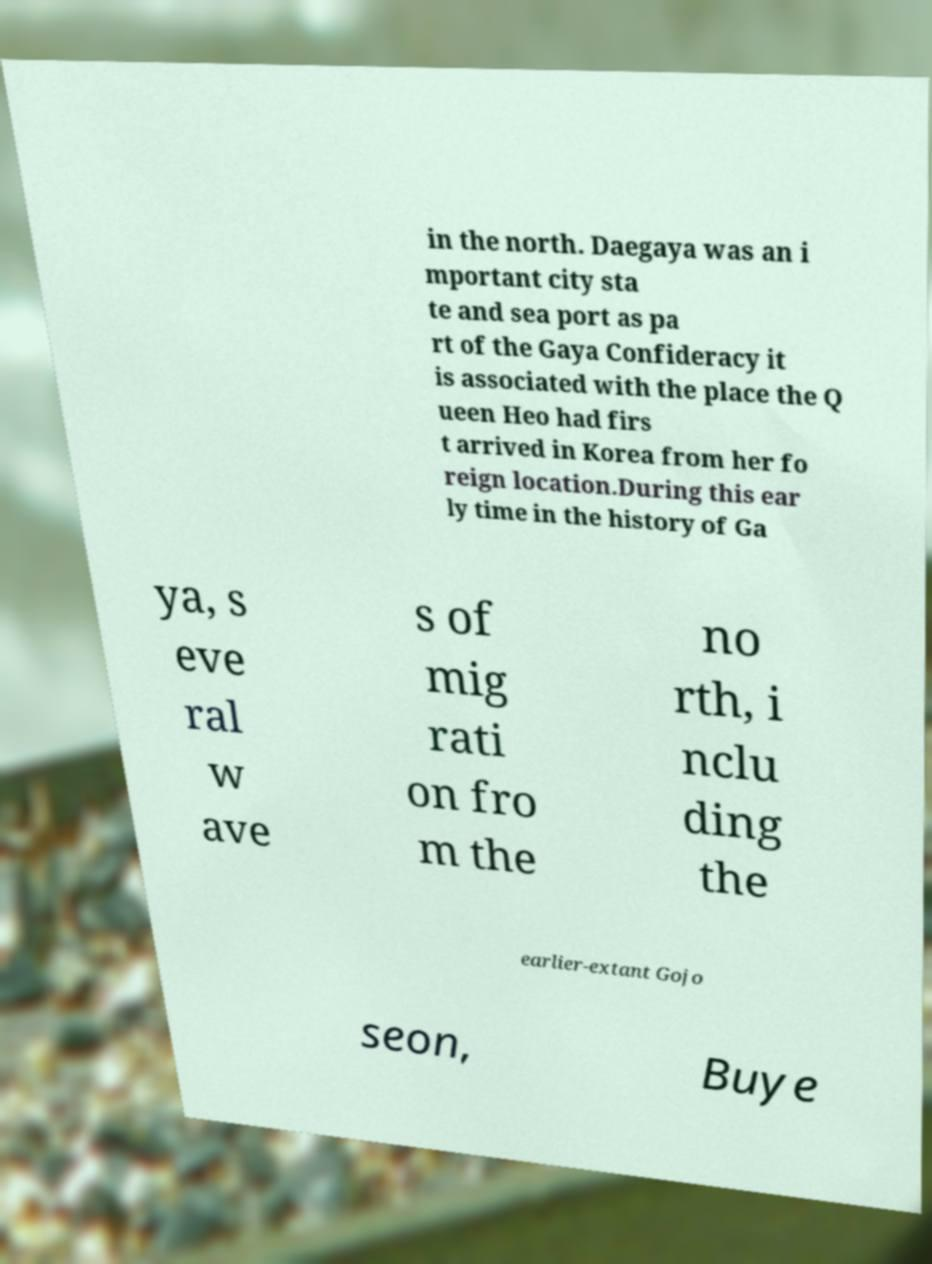Please read and relay the text visible in this image. What does it say? in the north. Daegaya was an i mportant city sta te and sea port as pa rt of the Gaya Confideracy it is associated with the place the Q ueen Heo had firs t arrived in Korea from her fo reign location.During this ear ly time in the history of Ga ya, s eve ral w ave s of mig rati on fro m the no rth, i nclu ding the earlier-extant Gojo seon, Buye 